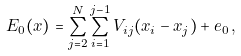<formula> <loc_0><loc_0><loc_500><loc_500>E _ { 0 } ( x ) = \sum _ { j = 2 } ^ { N } \sum _ { i = 1 } ^ { j - 1 } V _ { i j } ( x _ { i } - x _ { j } ) + e _ { 0 } \, ,</formula> 